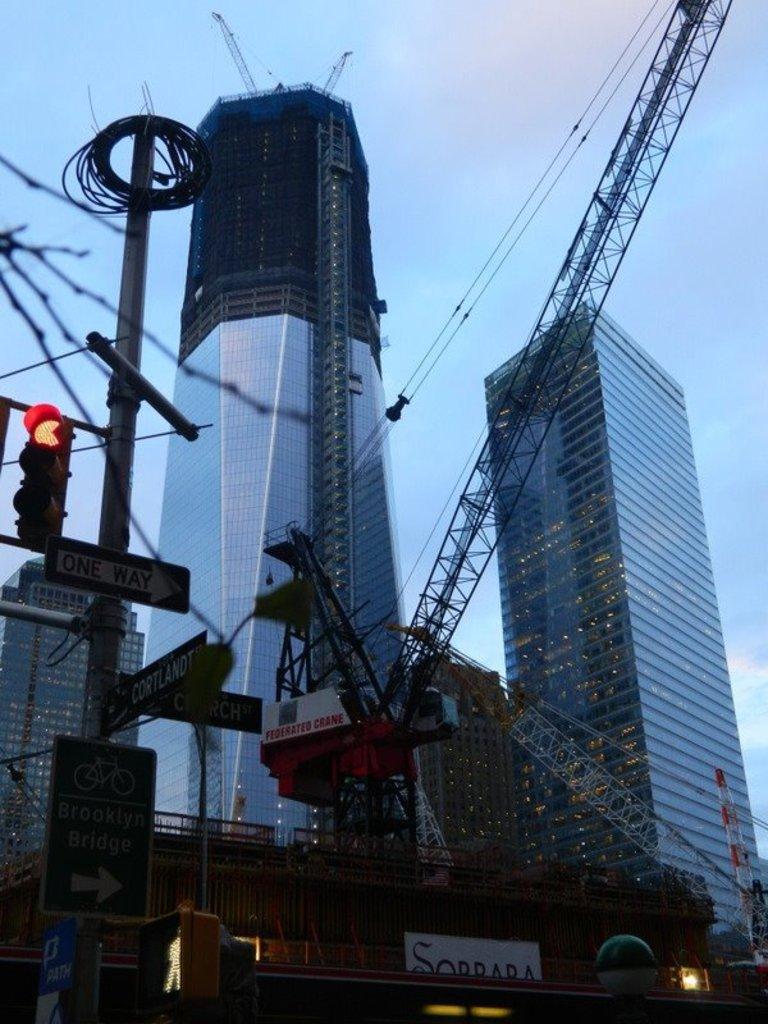Please provide a concise description of this image. In this image we can see a two skyscrapers are there and clear blue sky. There is a vehicle at the bottom of the image. Left most side of the image we can see a traffic light and a cable which is attached to a pole. 